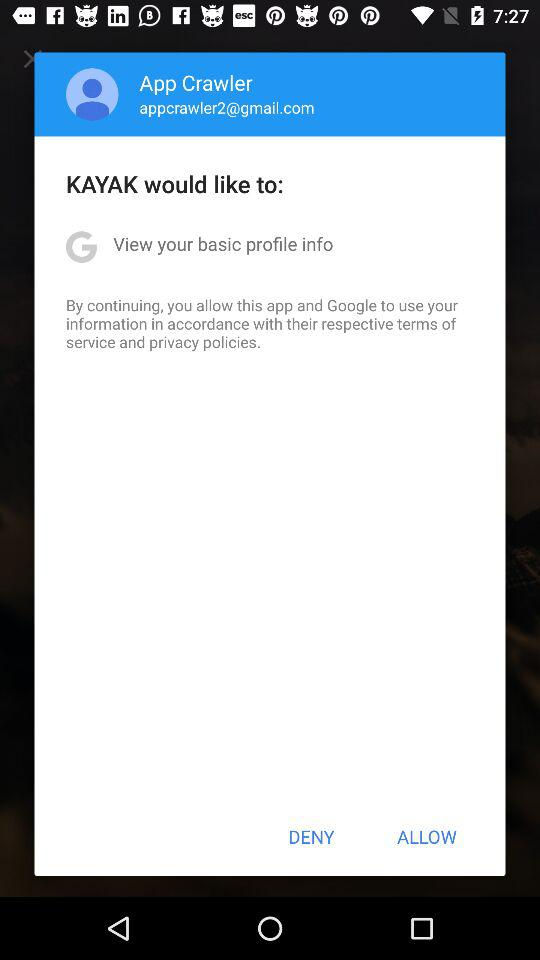What is the email address? The email address is "appcrawler2@gmail.com". 